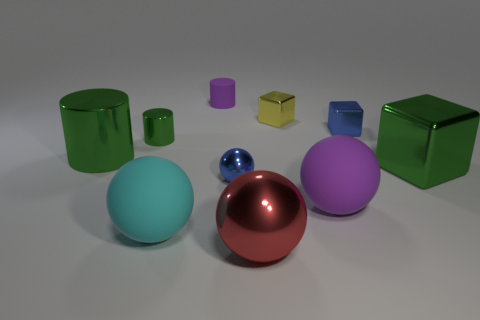The yellow thing that is made of the same material as the big red sphere is what shape?
Your response must be concise. Cube. Does the big green metallic thing that is right of the cyan sphere have the same shape as the yellow metal object?
Provide a succinct answer. Yes. There is a big green object left of the small yellow shiny object; what shape is it?
Make the answer very short. Cylinder. The small metallic object that is the same color as the large cylinder is what shape?
Offer a terse response. Cylinder. How many yellow cubes have the same size as the matte cylinder?
Provide a succinct answer. 1. What color is the large block?
Offer a terse response. Green. Do the tiny ball and the tiny shiny block in front of the small yellow metallic thing have the same color?
Your response must be concise. Yes. What is the size of the green block that is the same material as the big red ball?
Offer a terse response. Large. Is there a big block of the same color as the big cylinder?
Provide a succinct answer. Yes. How many things are either blue metal objects to the left of the tiny blue block or green metallic cylinders?
Your answer should be very brief. 3. 